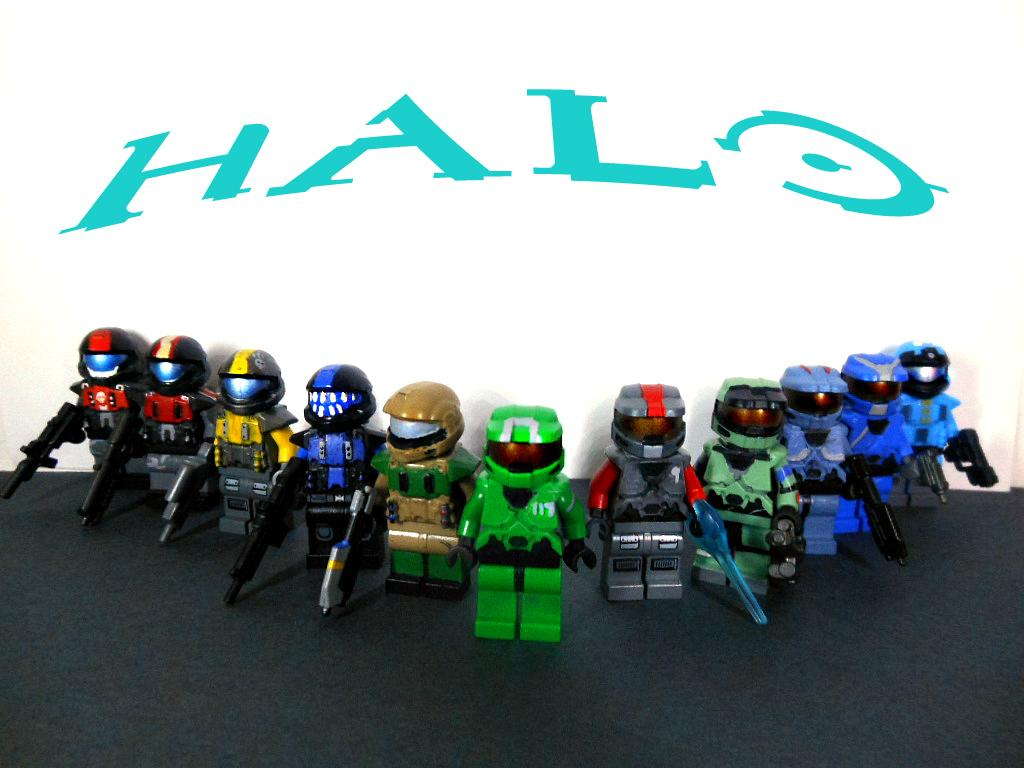What objects are present on the black surface in the image? There are toys on a black surface in the image. What can be seen in the background of the image? There is a white background with writing in the image. What type of weather can be seen through the window in the image? There is no window present in the image, so it is not possible to determine the weather. 